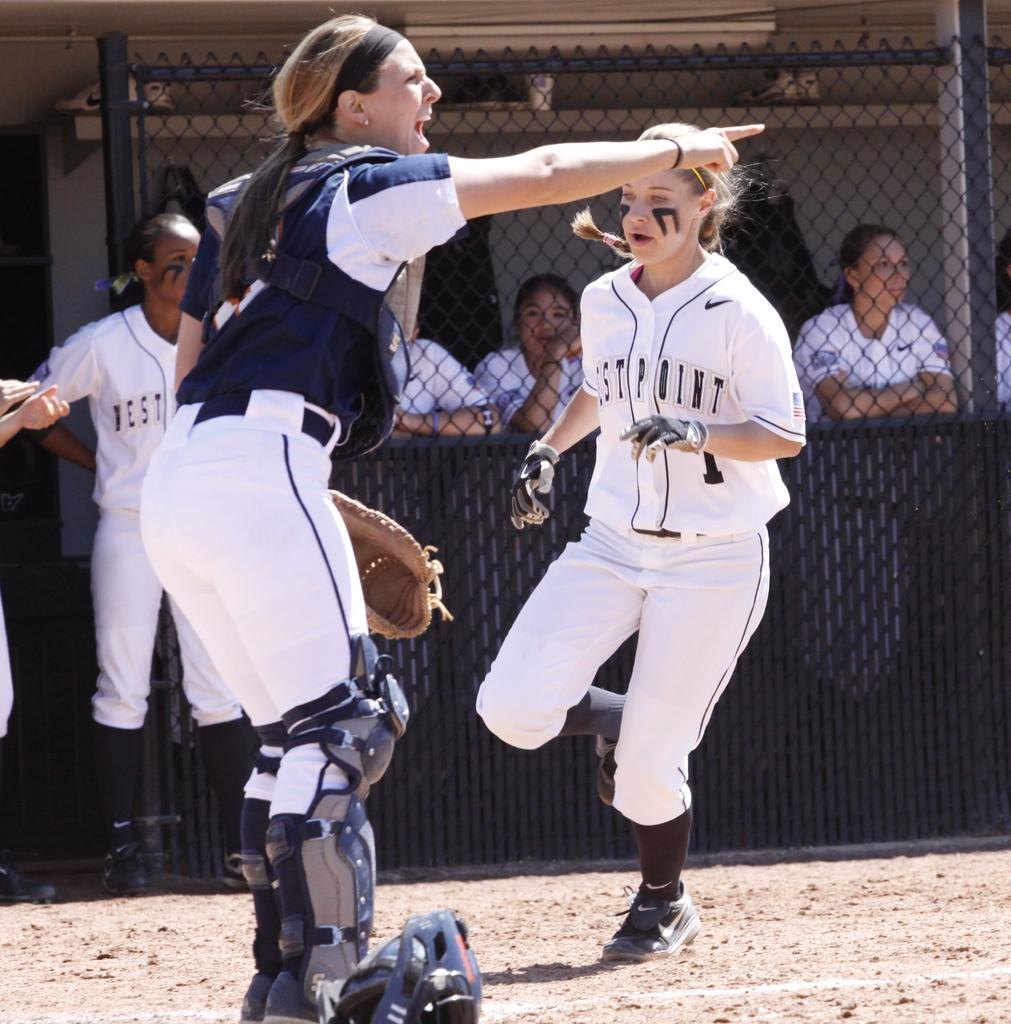Provide a one-sentence caption for the provided image. a player of Westpoint is running to the base. 